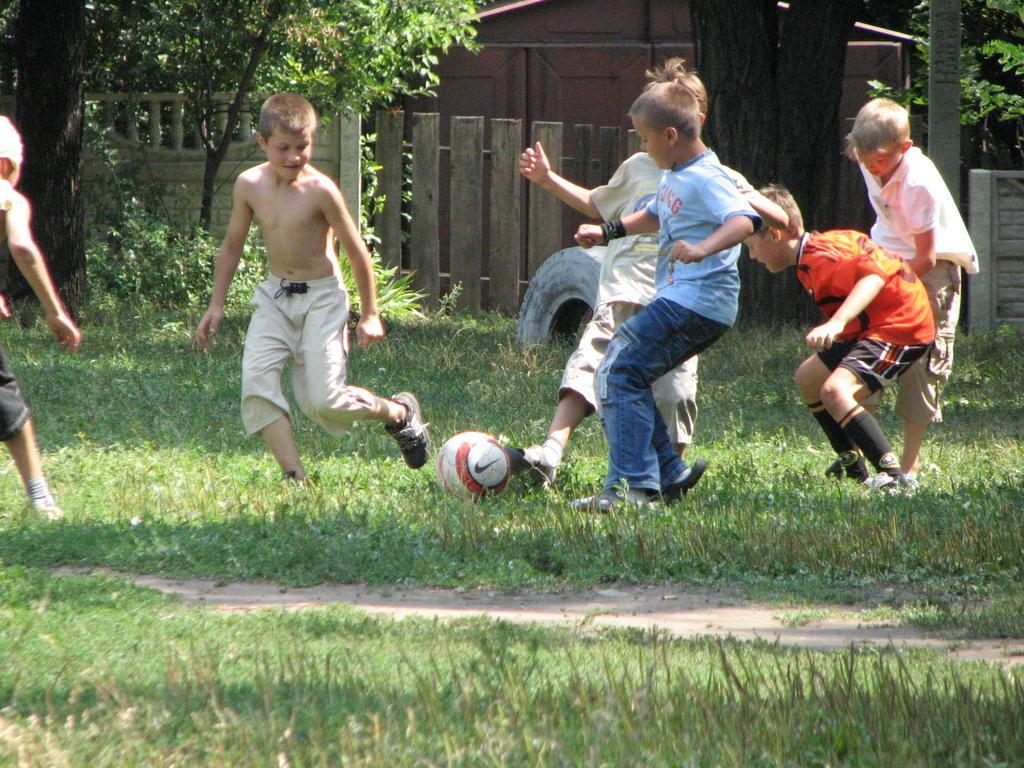In one or two sentences, can you explain what this image depicts? This picture is taken in the garden, There are some kids playing the football, In the background there is a black color tree and there are some plants in green color plants and trees and there is a brown color wall. 